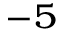Convert formula to latex. <formula><loc_0><loc_0><loc_500><loc_500>^ { - 5 }</formula> 